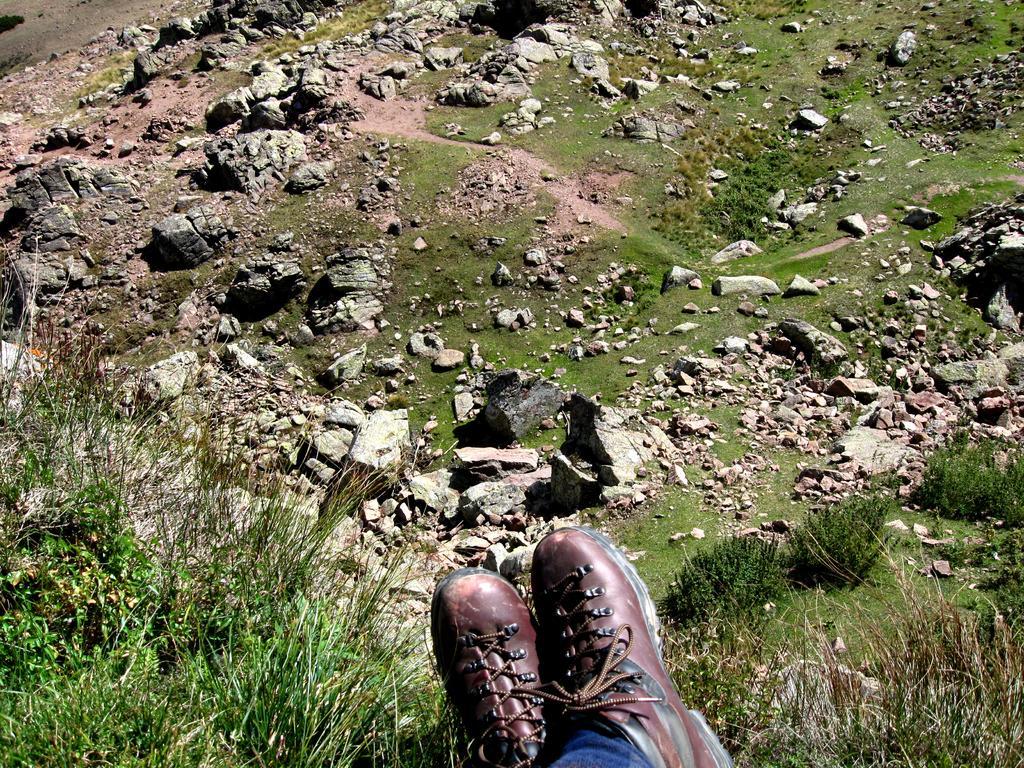In one or two sentences, can you explain what this image depicts? In this image we can see shares of a person at the bottom. There are plants. Also there are rocks on the ground. 